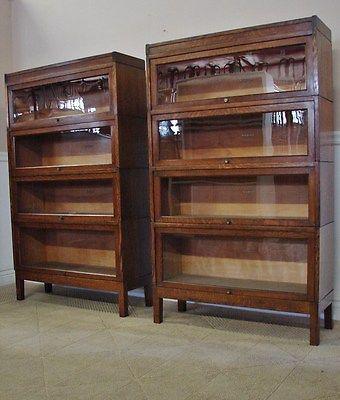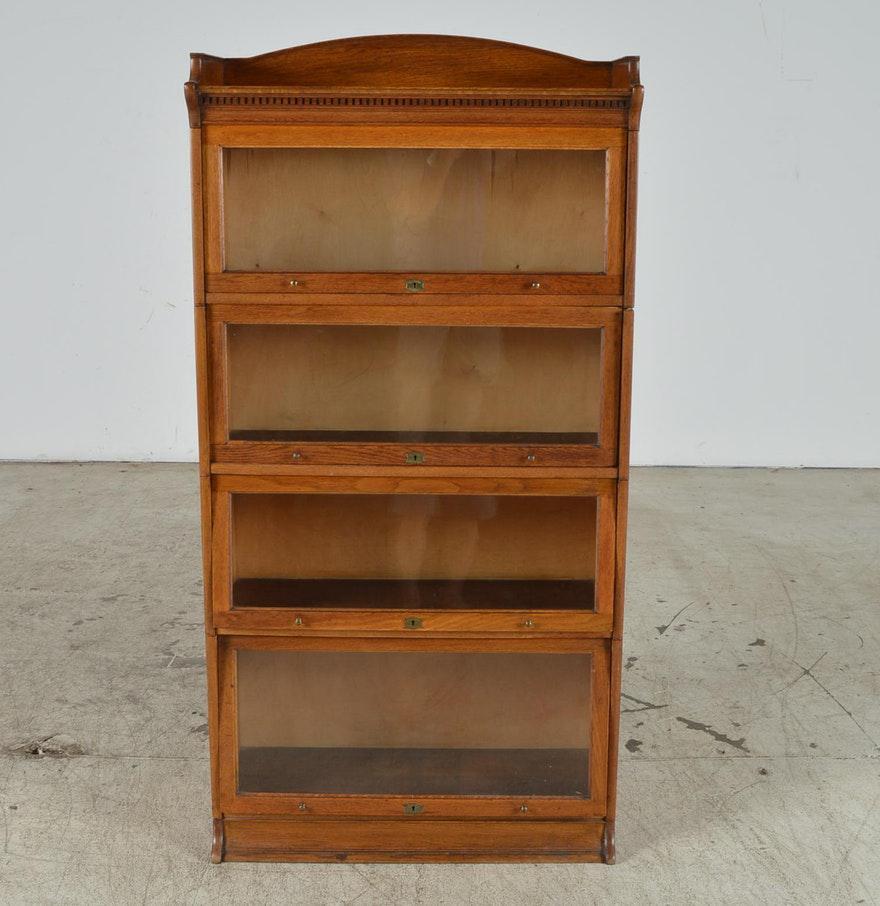The first image is the image on the left, the second image is the image on the right. Analyze the images presented: Is the assertion "there is a book case, outdoors with 3 shelves" valid? Answer yes or no. No. The first image is the image on the left, the second image is the image on the right. Given the left and right images, does the statement "One of the photos shows a wooden bookcase with at most three shelves." hold true? Answer yes or no. No. 